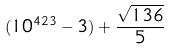Convert formula to latex. <formula><loc_0><loc_0><loc_500><loc_500>( 1 0 ^ { 4 2 3 } - 3 ) + \frac { \sqrt { 1 3 6 } } { 5 }</formula> 